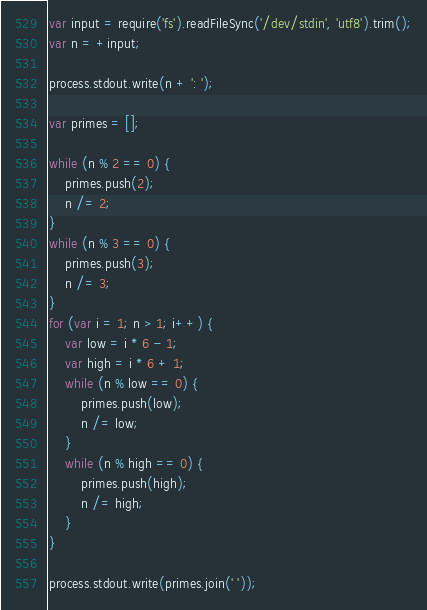Convert code to text. <code><loc_0><loc_0><loc_500><loc_500><_JavaScript_>var input = require('fs').readFileSync('/dev/stdin', 'utf8').trim();
var n = +input;
 
process.stdout.write(n + ': ');
 
var primes = [];
 
while (n % 2 == 0) {
    primes.push(2);
    n /= 2;
}
while (n % 3 == 0) {
    primes.push(3);
    n /= 3;
}
for (var i = 1; n > 1; i++) {
    var low = i * 6 - 1;
    var high = i * 6 + 1;
    while (n % low == 0) {
        primes.push(low);
        n /= low;
    }
    while (n % high == 0) {
        primes.push(high);
        n /= high;
    }
}
 
process.stdout.write(primes.join(' '));
</code> 